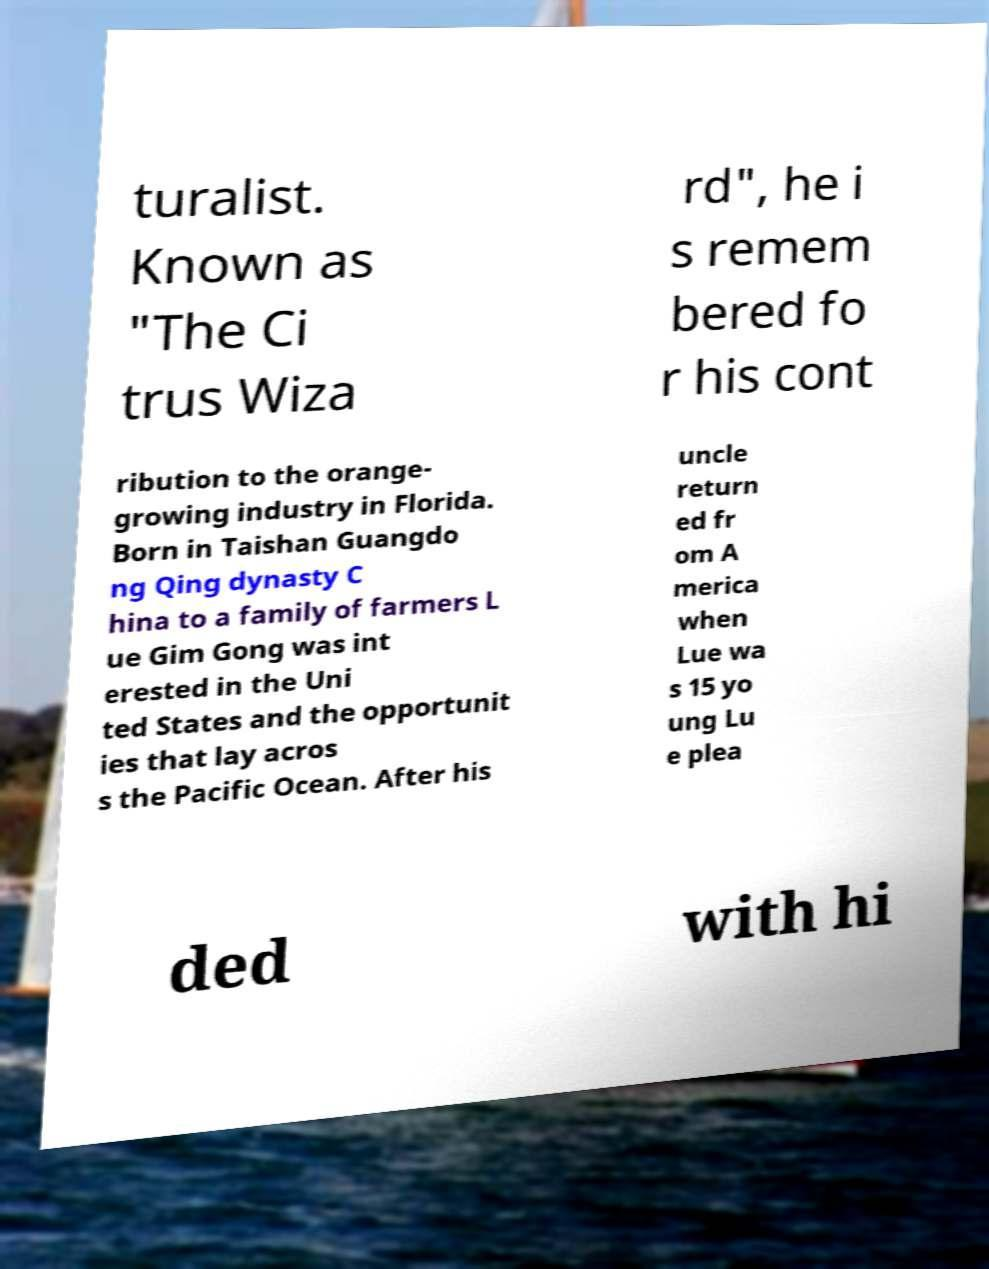Please identify and transcribe the text found in this image. turalist. Known as "The Ci trus Wiza rd", he i s remem bered fo r his cont ribution to the orange- growing industry in Florida. Born in Taishan Guangdo ng Qing dynasty C hina to a family of farmers L ue Gim Gong was int erested in the Uni ted States and the opportunit ies that lay acros s the Pacific Ocean. After his uncle return ed fr om A merica when Lue wa s 15 yo ung Lu e plea ded with hi 